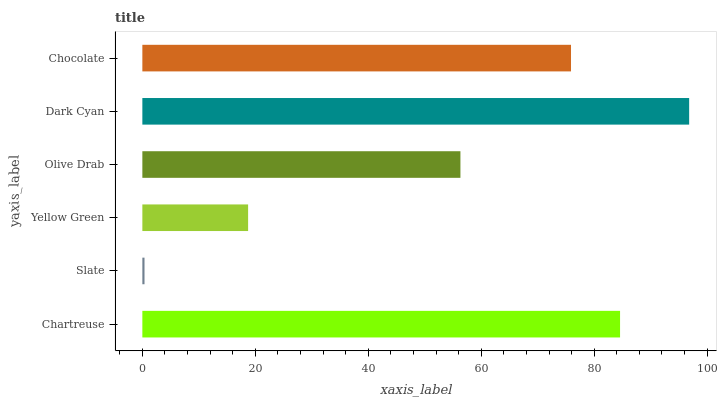Is Slate the minimum?
Answer yes or no. Yes. Is Dark Cyan the maximum?
Answer yes or no. Yes. Is Yellow Green the minimum?
Answer yes or no. No. Is Yellow Green the maximum?
Answer yes or no. No. Is Yellow Green greater than Slate?
Answer yes or no. Yes. Is Slate less than Yellow Green?
Answer yes or no. Yes. Is Slate greater than Yellow Green?
Answer yes or no. No. Is Yellow Green less than Slate?
Answer yes or no. No. Is Chocolate the high median?
Answer yes or no. Yes. Is Olive Drab the low median?
Answer yes or no. Yes. Is Slate the high median?
Answer yes or no. No. Is Dark Cyan the low median?
Answer yes or no. No. 